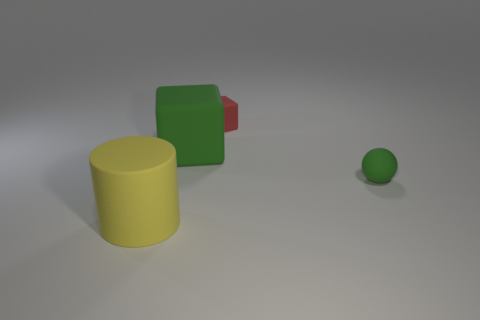The matte cylinder is what size?
Provide a short and direct response. Large. Is the number of green matte things that are in front of the green rubber block greater than the number of brown balls?
Provide a succinct answer. Yes. Does the tiny ball to the right of the red matte cube have the same color as the matte block left of the tiny rubber cube?
Offer a terse response. Yes. Are there more green rubber things than red matte cubes?
Provide a short and direct response. Yes. Is there anything else of the same color as the ball?
Offer a very short reply. Yes. There is a green cube that is the same material as the red cube; what size is it?
Give a very brief answer. Large. What material is the tiny green ball?
Your response must be concise. Rubber. What number of cyan rubber cylinders are the same size as the red thing?
Make the answer very short. 0. What is the shape of the tiny thing that is the same color as the big matte block?
Your answer should be very brief. Sphere. Are there any small green things that have the same shape as the large yellow object?
Your answer should be compact. No. 